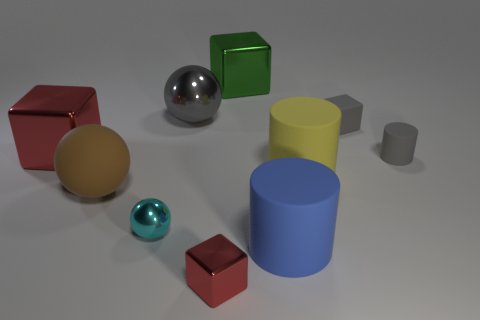Subtract all small rubber cylinders. How many cylinders are left? 2 Subtract all gray cylinders. How many cylinders are left? 2 Subtract 2 cylinders. How many cylinders are left? 1 Subtract all cylinders. How many objects are left? 7 Subtract all red cubes. Subtract all cyan cylinders. How many cubes are left? 2 Subtract all green blocks. How many yellow balls are left? 0 Subtract all gray metallic objects. Subtract all big cylinders. How many objects are left? 7 Add 5 matte cubes. How many matte cubes are left? 6 Add 1 green metallic spheres. How many green metallic spheres exist? 1 Subtract 0 yellow balls. How many objects are left? 10 